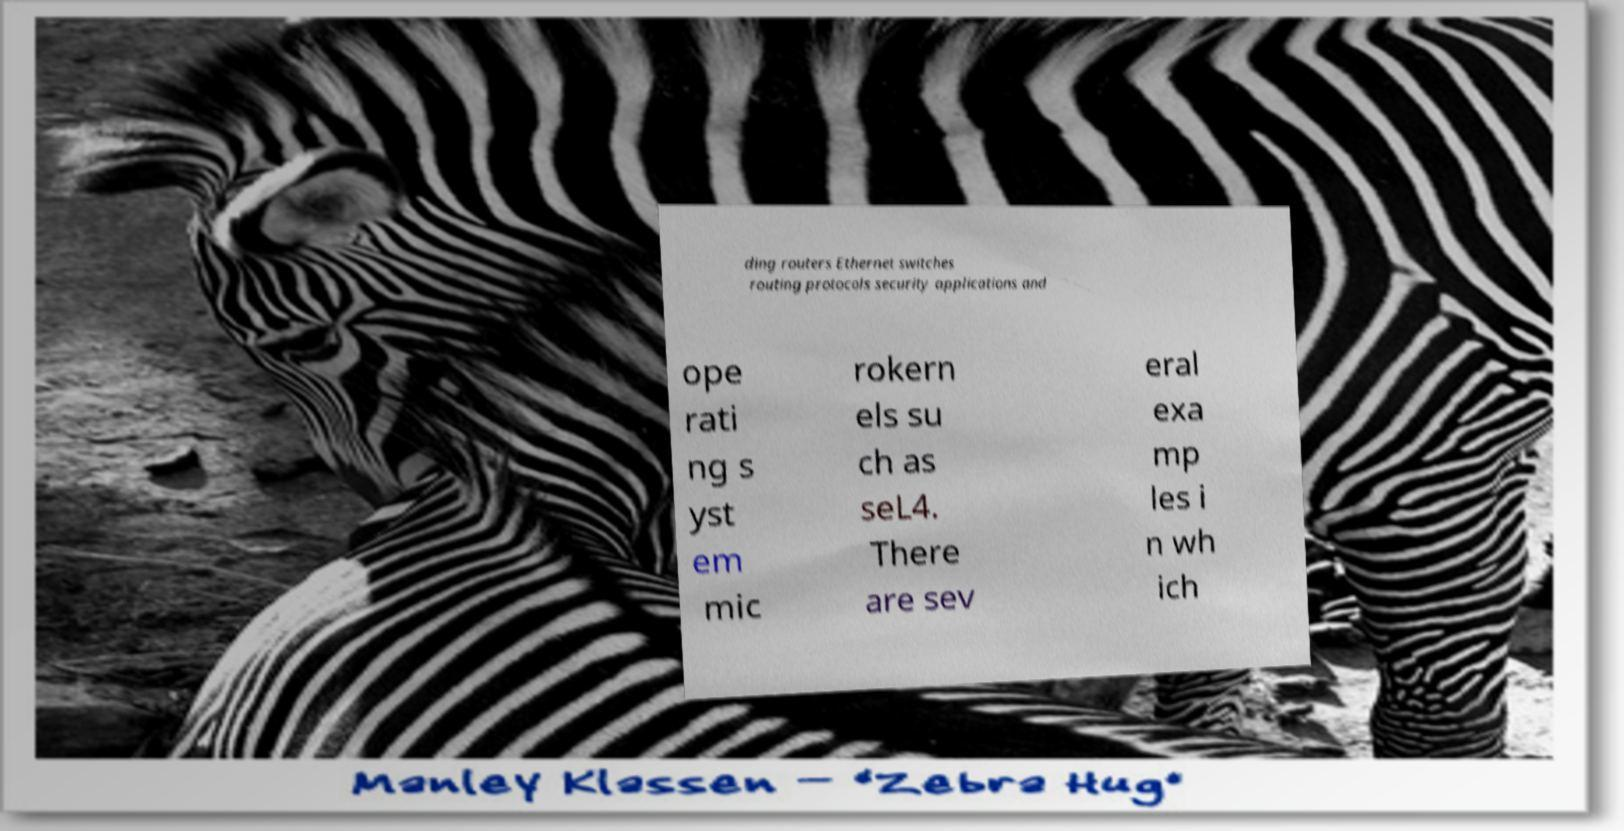Please read and relay the text visible in this image. What does it say? ding routers Ethernet switches routing protocols security applications and ope rati ng s yst em mic rokern els su ch as seL4. There are sev eral exa mp les i n wh ich 